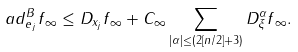Convert formula to latex. <formula><loc_0><loc_0><loc_500><loc_500>\| \ a d ^ { B } _ { e _ { j } } f \| _ { \infty } \leq \| D _ { x _ { j } } f \| _ { \infty } + C _ { \infty } \sum _ { | \alpha | \leq ( 2 [ n / 2 ] + 3 ) } \| D _ { \xi } ^ { \alpha } f \| _ { \infty } .</formula> 